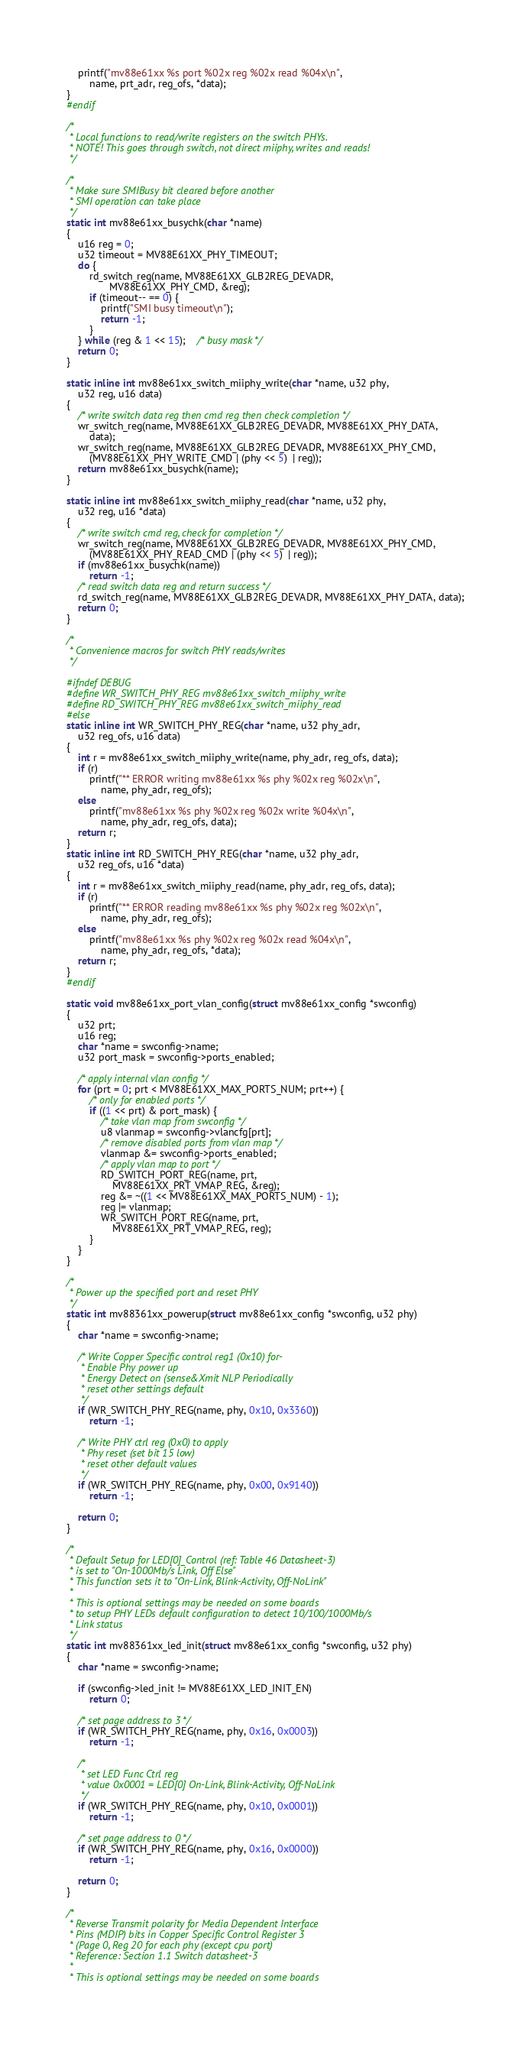<code> <loc_0><loc_0><loc_500><loc_500><_C_>	printf("mv88e61xx %s port %02x reg %02x read %04x\n",
		name, prt_adr, reg_ofs, *data);
}
#endif

/*
 * Local functions to read/write registers on the switch PHYs.
 * NOTE! This goes through switch, not direct miiphy, writes and reads!
 */

/*
 * Make sure SMIBusy bit cleared before another
 * SMI operation can take place
 */
static int mv88e61xx_busychk(char *name)
{
	u16 reg = 0;
	u32 timeout = MV88E61XX_PHY_TIMEOUT;
	do {
		rd_switch_reg(name, MV88E61XX_GLB2REG_DEVADR,
		       MV88E61XX_PHY_CMD, &reg);
		if (timeout-- == 0) {
			printf("SMI busy timeout\n");
			return -1;
		}
	} while (reg & 1 << 15);	/* busy mask */
	return 0;
}

static inline int mv88e61xx_switch_miiphy_write(char *name, u32 phy,
	u32 reg, u16 data)
{
	/* write switch data reg then cmd reg then check completion */
	wr_switch_reg(name, MV88E61XX_GLB2REG_DEVADR, MV88E61XX_PHY_DATA,
		data);
	wr_switch_reg(name, MV88E61XX_GLB2REG_DEVADR, MV88E61XX_PHY_CMD,
		(MV88E61XX_PHY_WRITE_CMD | (phy << 5)  | reg));
	return mv88e61xx_busychk(name);
}

static inline int mv88e61xx_switch_miiphy_read(char *name, u32 phy,
	u32 reg, u16 *data)
{
	/* write switch cmd reg, check for completion */
	wr_switch_reg(name, MV88E61XX_GLB2REG_DEVADR, MV88E61XX_PHY_CMD,
		(MV88E61XX_PHY_READ_CMD | (phy << 5)  | reg));
	if (mv88e61xx_busychk(name))
		return -1;
	/* read switch data reg and return success */
	rd_switch_reg(name, MV88E61XX_GLB2REG_DEVADR, MV88E61XX_PHY_DATA, data);
	return 0;
}

/*
 * Convenience macros for switch PHY reads/writes
 */

#ifndef DEBUG
#define WR_SWITCH_PHY_REG mv88e61xx_switch_miiphy_write
#define RD_SWITCH_PHY_REG mv88e61xx_switch_miiphy_read
#else
static inline int WR_SWITCH_PHY_REG(char *name, u32 phy_adr,
	u32 reg_ofs, u16 data)
{
	int r = mv88e61xx_switch_miiphy_write(name, phy_adr, reg_ofs, data);
	if (r)
		printf("** ERROR writing mv88e61xx %s phy %02x reg %02x\n",
			name, phy_adr, reg_ofs);
	else
		printf("mv88e61xx %s phy %02x reg %02x write %04x\n",
			name, phy_adr, reg_ofs, data);
	return r;
}
static inline int RD_SWITCH_PHY_REG(char *name, u32 phy_adr,
	u32 reg_ofs, u16 *data)
{
	int r = mv88e61xx_switch_miiphy_read(name, phy_adr, reg_ofs, data);
	if (r)
		printf("** ERROR reading mv88e61xx %s phy %02x reg %02x\n",
			name, phy_adr, reg_ofs);
	else
		printf("mv88e61xx %s phy %02x reg %02x read %04x\n",
			name, phy_adr, reg_ofs, *data);
	return r;
}
#endif

static void mv88e61xx_port_vlan_config(struct mv88e61xx_config *swconfig)
{
	u32 prt;
	u16 reg;
	char *name = swconfig->name;
	u32 port_mask = swconfig->ports_enabled;

	/* apply internal vlan config */
	for (prt = 0; prt < MV88E61XX_MAX_PORTS_NUM; prt++) {
		/* only for enabled ports */
		if ((1 << prt) & port_mask) {
			/* take vlan map from swconfig */
			u8 vlanmap = swconfig->vlancfg[prt];
			/* remove disabled ports from vlan map */
			vlanmap &= swconfig->ports_enabled;
			/* apply vlan map to port */
			RD_SWITCH_PORT_REG(name, prt,
				MV88E61XX_PRT_VMAP_REG, &reg);
			reg &= ~((1 << MV88E61XX_MAX_PORTS_NUM) - 1);
			reg |= vlanmap;
			WR_SWITCH_PORT_REG(name, prt,
				MV88E61XX_PRT_VMAP_REG, reg);
		}
	}
}

/*
 * Power up the specified port and reset PHY
 */
static int mv88361xx_powerup(struct mv88e61xx_config *swconfig, u32 phy)
{
	char *name = swconfig->name;

	/* Write Copper Specific control reg1 (0x10) for-
	 * Enable Phy power up
	 * Energy Detect on (sense&Xmit NLP Periodically
	 * reset other settings default
	 */
	if (WR_SWITCH_PHY_REG(name, phy, 0x10, 0x3360))
		return -1;

	/* Write PHY ctrl reg (0x0) to apply
	 * Phy reset (set bit 15 low)
	 * reset other default values
	 */
	if (WR_SWITCH_PHY_REG(name, phy, 0x00, 0x9140))
		return -1;

	return 0;
}

/*
 * Default Setup for LED[0]_Control (ref: Table 46 Datasheet-3)
 * is set to "On-1000Mb/s Link, Off Else"
 * This function sets it to "On-Link, Blink-Activity, Off-NoLink"
 *
 * This is optional settings may be needed on some boards
 * to setup PHY LEDs default configuration to detect 10/100/1000Mb/s
 * Link status
 */
static int mv88361xx_led_init(struct mv88e61xx_config *swconfig, u32 phy)
{
	char *name = swconfig->name;

	if (swconfig->led_init != MV88E61XX_LED_INIT_EN)
		return 0;

	/* set page address to 3 */
	if (WR_SWITCH_PHY_REG(name, phy, 0x16, 0x0003))
		return -1;

	/*
	 * set LED Func Ctrl reg
	 * value 0x0001 = LED[0] On-Link, Blink-Activity, Off-NoLink
	 */
	if (WR_SWITCH_PHY_REG(name, phy, 0x10, 0x0001))
		return -1;

	/* set page address to 0 */
	if (WR_SWITCH_PHY_REG(name, phy, 0x16, 0x0000))
		return -1;

	return 0;
}

/*
 * Reverse Transmit polarity for Media Dependent Interface
 * Pins (MDIP) bits in Copper Specific Control Register 3
 * (Page 0, Reg 20 for each phy (except cpu port)
 * Reference: Section 1.1 Switch datasheet-3
 *
 * This is optional settings may be needed on some boards</code> 